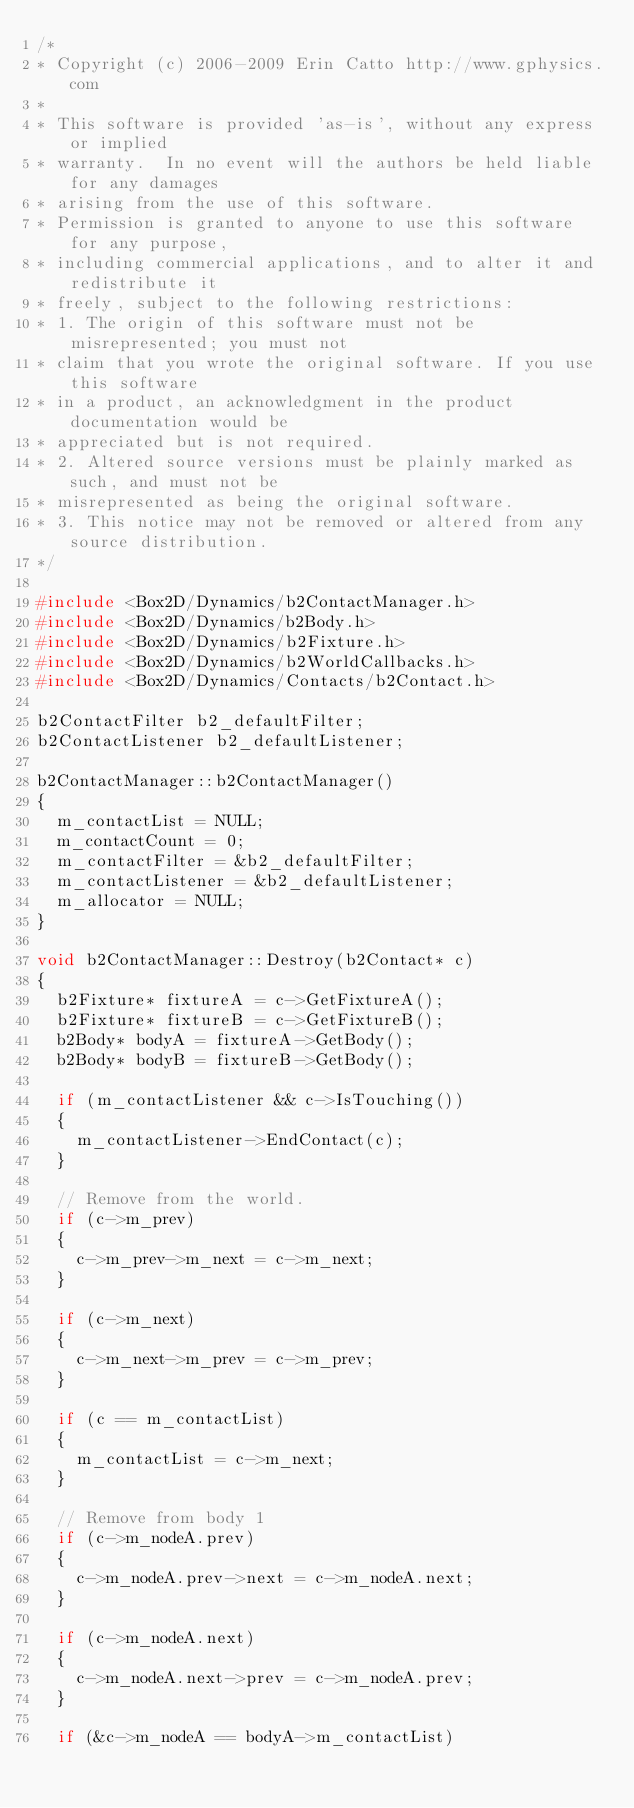<code> <loc_0><loc_0><loc_500><loc_500><_C++_>/*
* Copyright (c) 2006-2009 Erin Catto http://www.gphysics.com
*
* This software is provided 'as-is', without any express or implied
* warranty.  In no event will the authors be held liable for any damages
* arising from the use of this software.
* Permission is granted to anyone to use this software for any purpose,
* including commercial applications, and to alter it and redistribute it
* freely, subject to the following restrictions:
* 1. The origin of this software must not be misrepresented; you must not
* claim that you wrote the original software. If you use this software
* in a product, an acknowledgment in the product documentation would be
* appreciated but is not required.
* 2. Altered source versions must be plainly marked as such, and must not be
* misrepresented as being the original software.
* 3. This notice may not be removed or altered from any source distribution.
*/

#include <Box2D/Dynamics/b2ContactManager.h>
#include <Box2D/Dynamics/b2Body.h>
#include <Box2D/Dynamics/b2Fixture.h>
#include <Box2D/Dynamics/b2WorldCallbacks.h>
#include <Box2D/Dynamics/Contacts/b2Contact.h>

b2ContactFilter b2_defaultFilter;
b2ContactListener b2_defaultListener;

b2ContactManager::b2ContactManager()
{
	m_contactList = NULL;
	m_contactCount = 0;
	m_contactFilter = &b2_defaultFilter;
	m_contactListener = &b2_defaultListener;
	m_allocator = NULL;
}

void b2ContactManager::Destroy(b2Contact* c)
{
	b2Fixture* fixtureA = c->GetFixtureA();
	b2Fixture* fixtureB = c->GetFixtureB();
	b2Body* bodyA = fixtureA->GetBody();
	b2Body* bodyB = fixtureB->GetBody();

	if (m_contactListener && c->IsTouching())
	{
		m_contactListener->EndContact(c);
	}

	// Remove from the world.
	if (c->m_prev)
	{
		c->m_prev->m_next = c->m_next;
	}

	if (c->m_next)
	{
		c->m_next->m_prev = c->m_prev;
	}

	if (c == m_contactList)
	{
		m_contactList = c->m_next;
	}

	// Remove from body 1
	if (c->m_nodeA.prev)
	{
		c->m_nodeA.prev->next = c->m_nodeA.next;
	}

	if (c->m_nodeA.next)
	{
		c->m_nodeA.next->prev = c->m_nodeA.prev;
	}

	if (&c->m_nodeA == bodyA->m_contactList)</code> 